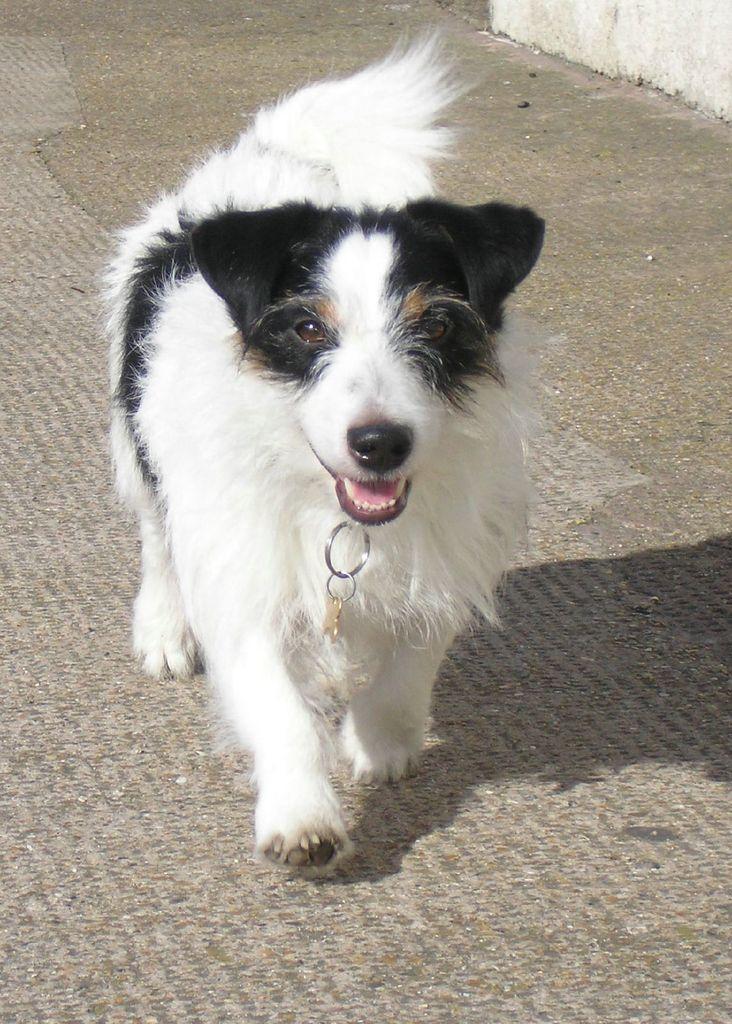Can you describe this image briefly? In this image we can see a dog on the ground. 